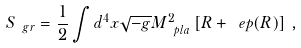<formula> <loc_0><loc_0><loc_500><loc_500>S _ { \ g r } = \frac { 1 } { 2 } \int d ^ { 4 } x \sqrt { - g } M _ { \ p l a } ^ { 2 } \left [ R + \ e p ( R ) \right ] \, ,</formula> 